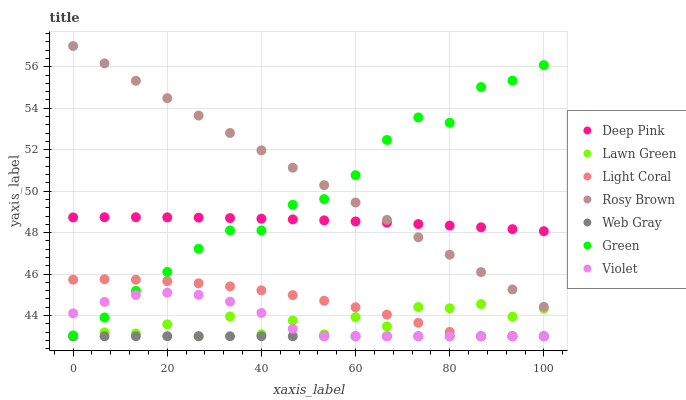Does Web Gray have the minimum area under the curve?
Answer yes or no. Yes. Does Rosy Brown have the maximum area under the curve?
Answer yes or no. Yes. Does Deep Pink have the minimum area under the curve?
Answer yes or no. No. Does Deep Pink have the maximum area under the curve?
Answer yes or no. No. Is Rosy Brown the smoothest?
Answer yes or no. Yes. Is Lawn Green the roughest?
Answer yes or no. Yes. Is Deep Pink the smoothest?
Answer yes or no. No. Is Deep Pink the roughest?
Answer yes or no. No. Does Lawn Green have the lowest value?
Answer yes or no. Yes. Does Rosy Brown have the lowest value?
Answer yes or no. No. Does Rosy Brown have the highest value?
Answer yes or no. Yes. Does Deep Pink have the highest value?
Answer yes or no. No. Is Lawn Green less than Green?
Answer yes or no. Yes. Is Rosy Brown greater than Web Gray?
Answer yes or no. Yes. Does Light Coral intersect Violet?
Answer yes or no. Yes. Is Light Coral less than Violet?
Answer yes or no. No. Is Light Coral greater than Violet?
Answer yes or no. No. Does Lawn Green intersect Green?
Answer yes or no. No. 